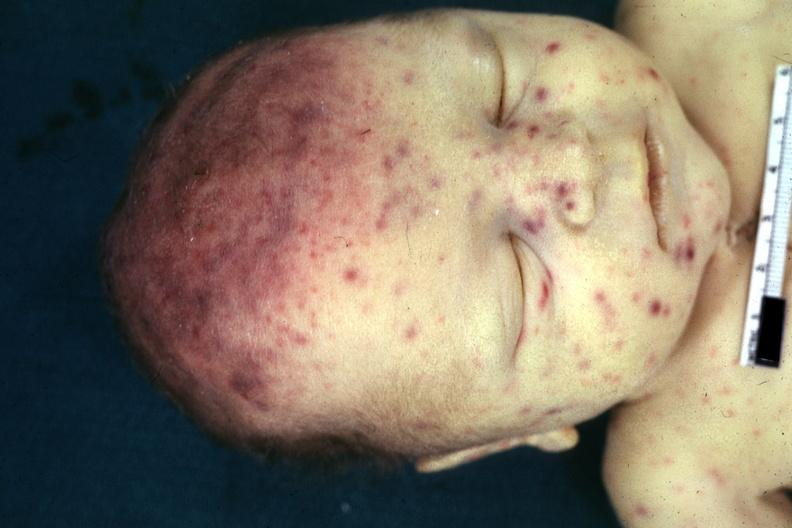s cytomegalic inclusion virus infection in infant present?
Answer the question using a single word or phrase. Yes 